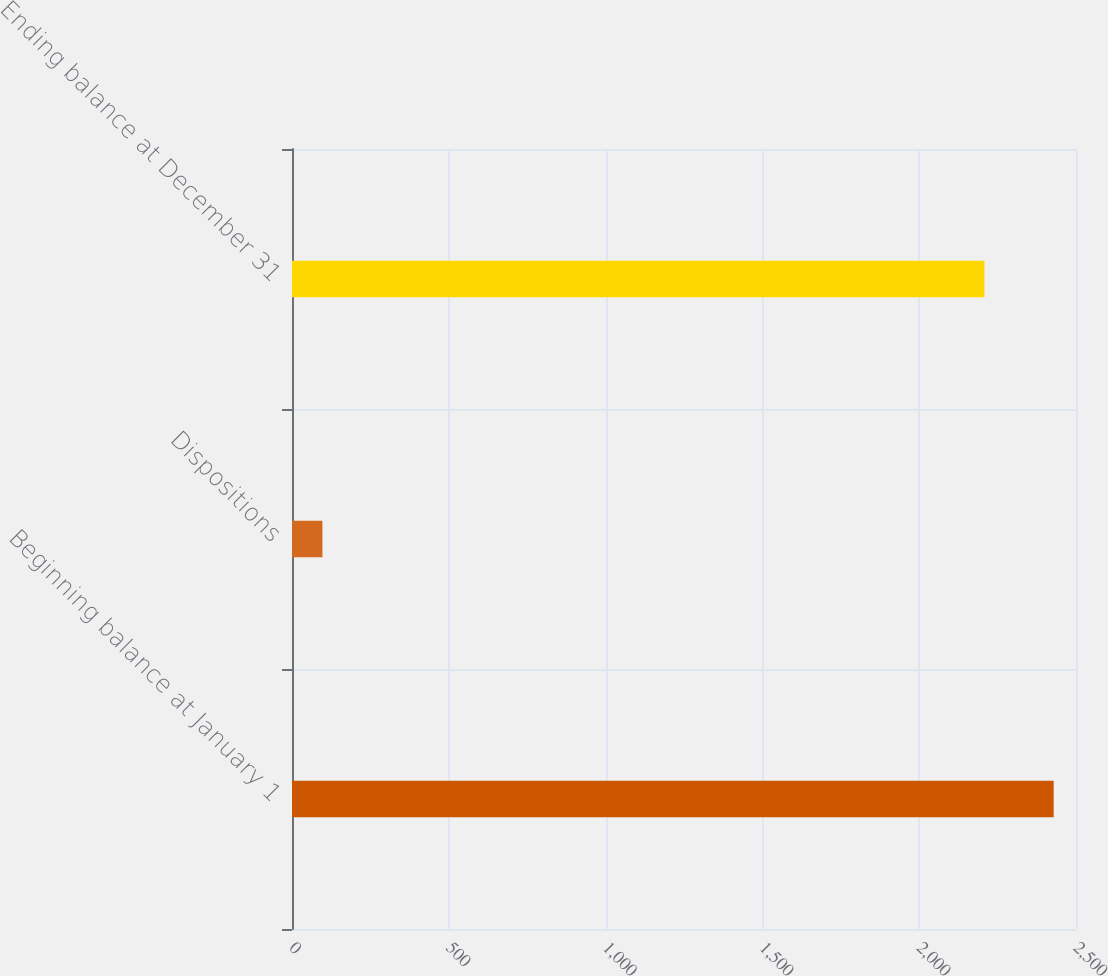Convert chart to OTSL. <chart><loc_0><loc_0><loc_500><loc_500><bar_chart><fcel>Beginning balance at January 1<fcel>Dispositions<fcel>Ending balance at December 31<nl><fcel>2428.8<fcel>97<fcel>2208<nl></chart> 